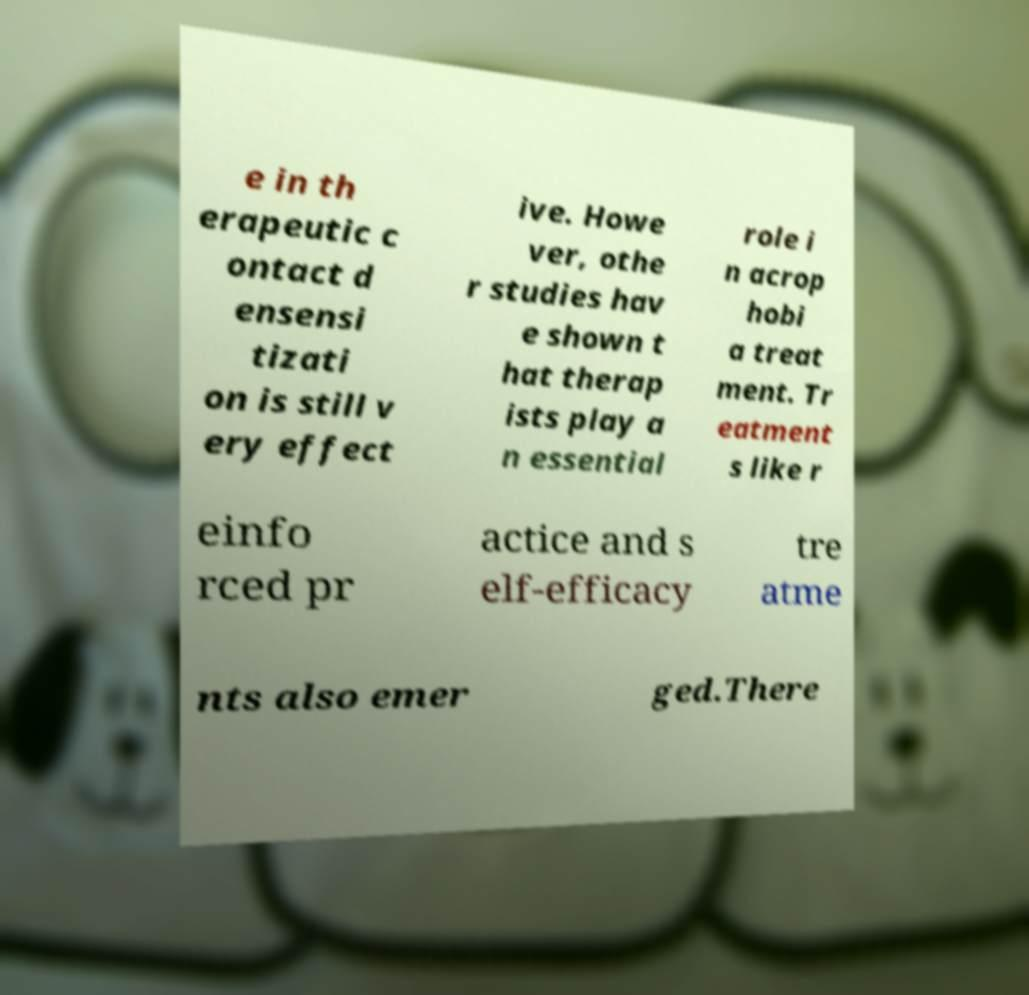Can you accurately transcribe the text from the provided image for me? e in th erapeutic c ontact d ensensi tizati on is still v ery effect ive. Howe ver, othe r studies hav e shown t hat therap ists play a n essential role i n acrop hobi a treat ment. Tr eatment s like r einfo rced pr actice and s elf-efficacy tre atme nts also emer ged.There 